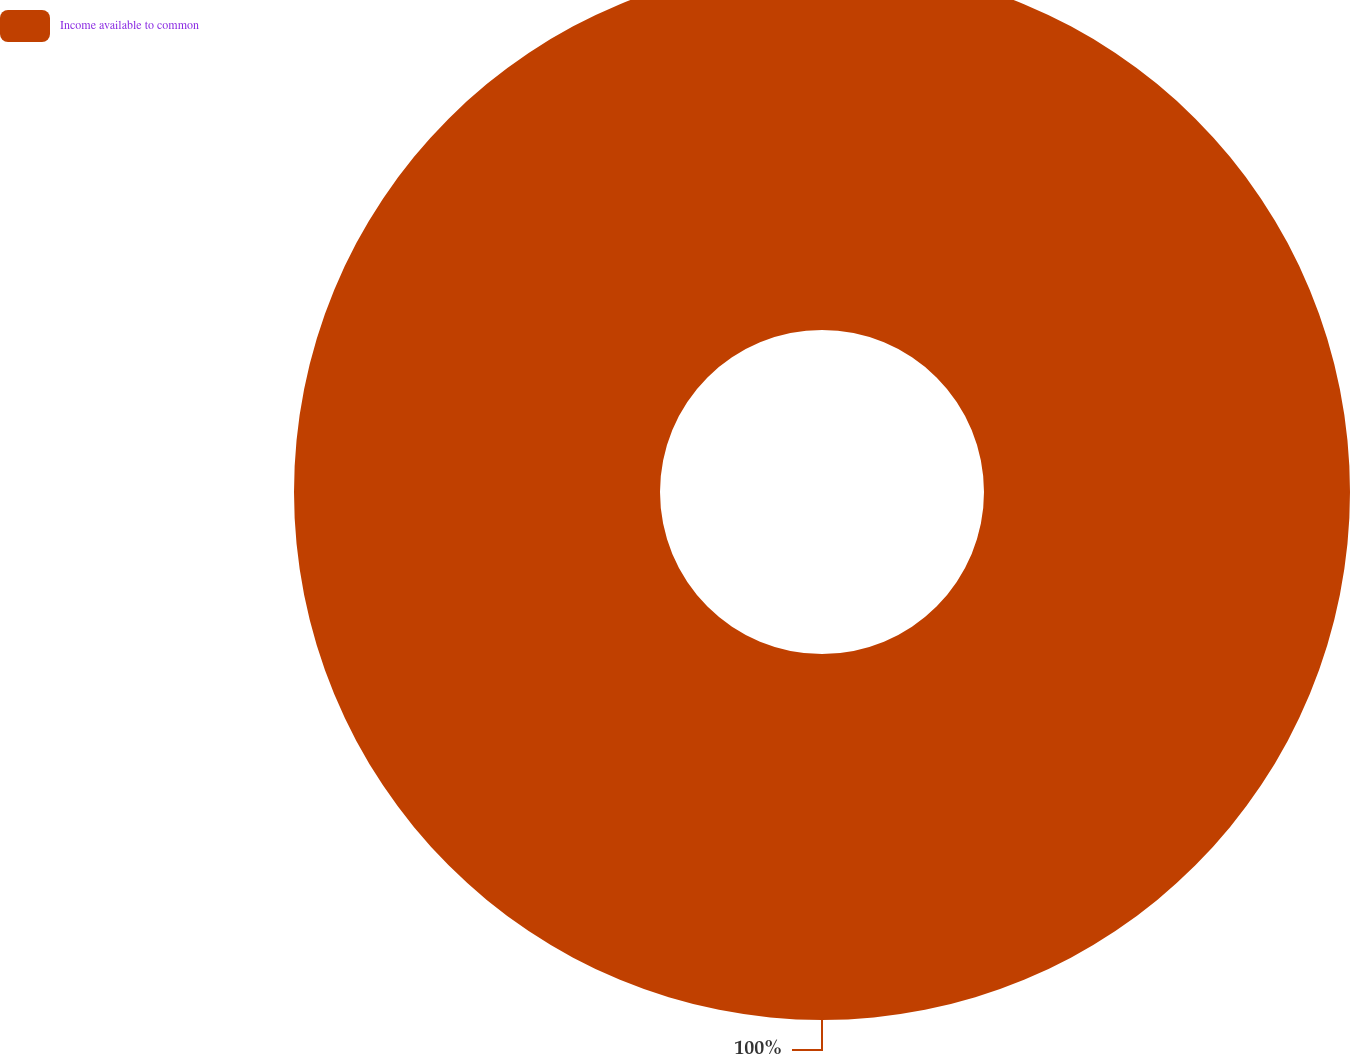Convert chart to OTSL. <chart><loc_0><loc_0><loc_500><loc_500><pie_chart><fcel>Income available to common<nl><fcel>100.0%<nl></chart> 